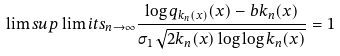<formula> <loc_0><loc_0><loc_500><loc_500>\lim s u p \lim i t s _ { n \to \infty } \frac { \log q _ { k _ { n } ( x ) } ( x ) - b k _ { n } ( x ) } { \sigma _ { 1 } \sqrt { 2 k _ { n } ( x ) \log \log k _ { n } ( x ) } } = 1</formula> 